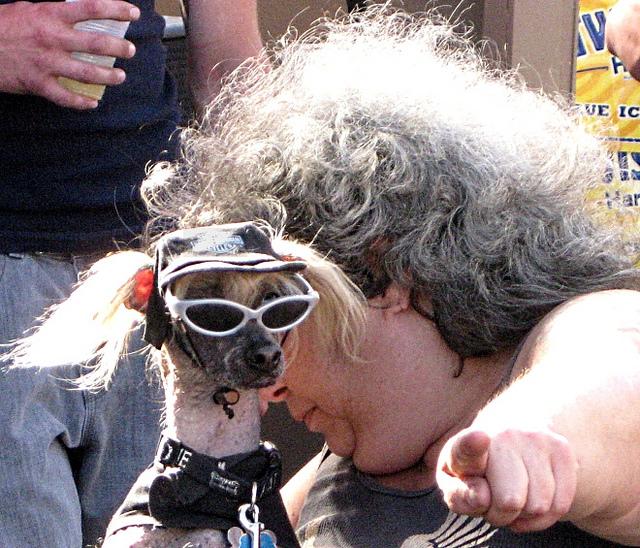What direction is the dog looking?
Give a very brief answer. Forward. What breed of dog is that?
Write a very short answer. Chinese crested. What color is the lady's hair?
Quick response, please. Gray. 